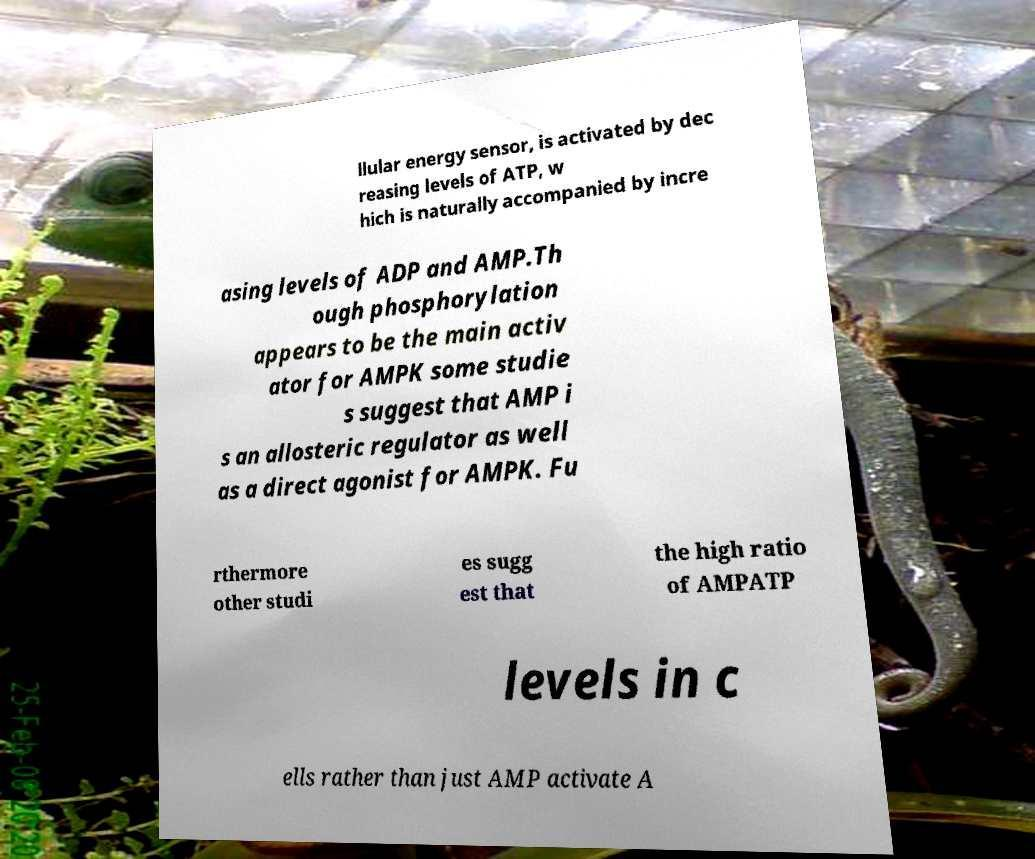There's text embedded in this image that I need extracted. Can you transcribe it verbatim? llular energy sensor, is activated by dec reasing levels of ATP, w hich is naturally accompanied by incre asing levels of ADP and AMP.Th ough phosphorylation appears to be the main activ ator for AMPK some studie s suggest that AMP i s an allosteric regulator as well as a direct agonist for AMPK. Fu rthermore other studi es sugg est that the high ratio of AMPATP levels in c ells rather than just AMP activate A 